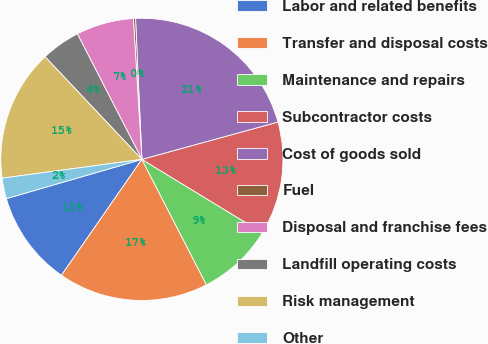<chart> <loc_0><loc_0><loc_500><loc_500><pie_chart><fcel>Labor and related benefits<fcel>Transfer and disposal costs<fcel>Maintenance and repairs<fcel>Subcontractor costs<fcel>Cost of goods sold<fcel>Fuel<fcel>Disposal and franchise fees<fcel>Landfill operating costs<fcel>Risk management<fcel>Other<nl><fcel>10.85%<fcel>17.22%<fcel>8.73%<fcel>12.97%<fcel>21.46%<fcel>0.24%<fcel>6.6%<fcel>4.48%<fcel>15.09%<fcel>2.36%<nl></chart> 